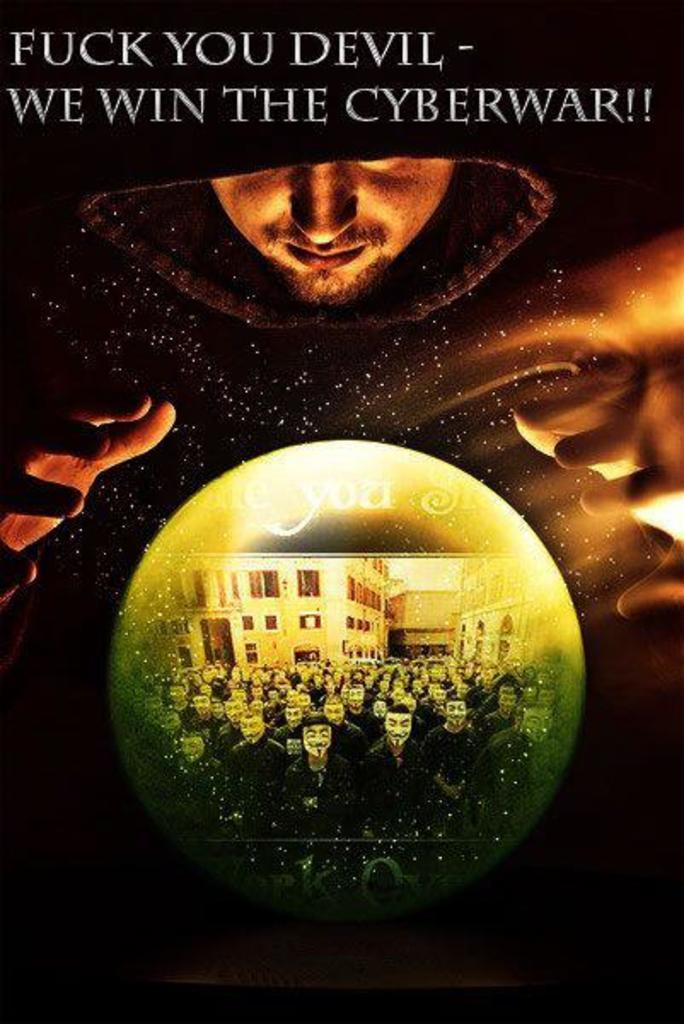<image>
Relay a brief, clear account of the picture shown. We Win The Cyberwar is posted on the poster 